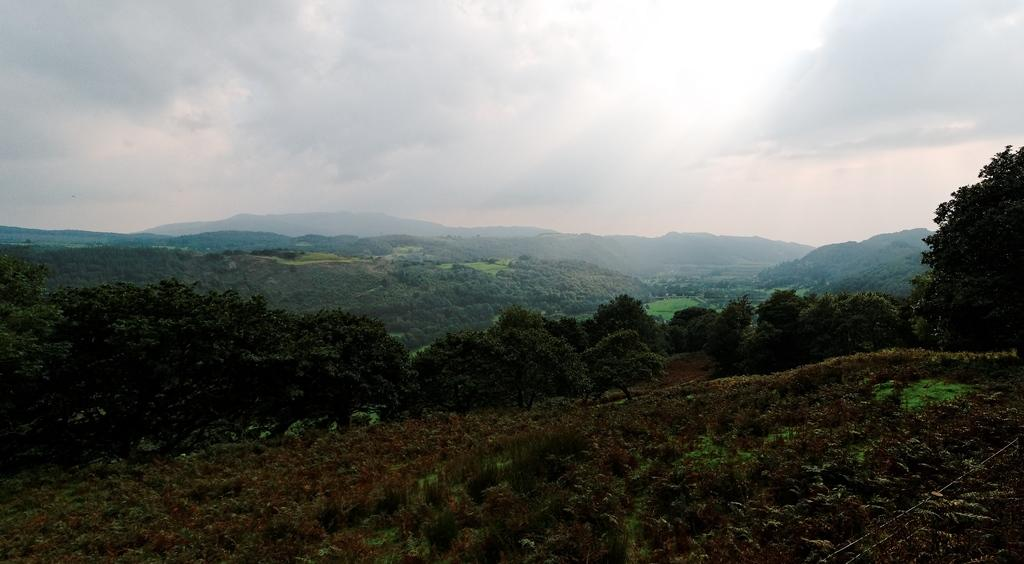What type of vegetation is present in the image? There is grass, plants, and trees in the image. What natural features can be seen in the image? There are mountains in the image. What part of the sky is visible in the image? The sky is visible at the top of the image. What type of location might the image depict? The image may have been taken near a hill station. Can you see your dad sitting on a chair in the image? There is no chair or person present in the image, so it is not possible to see your dad sitting on a chair. 